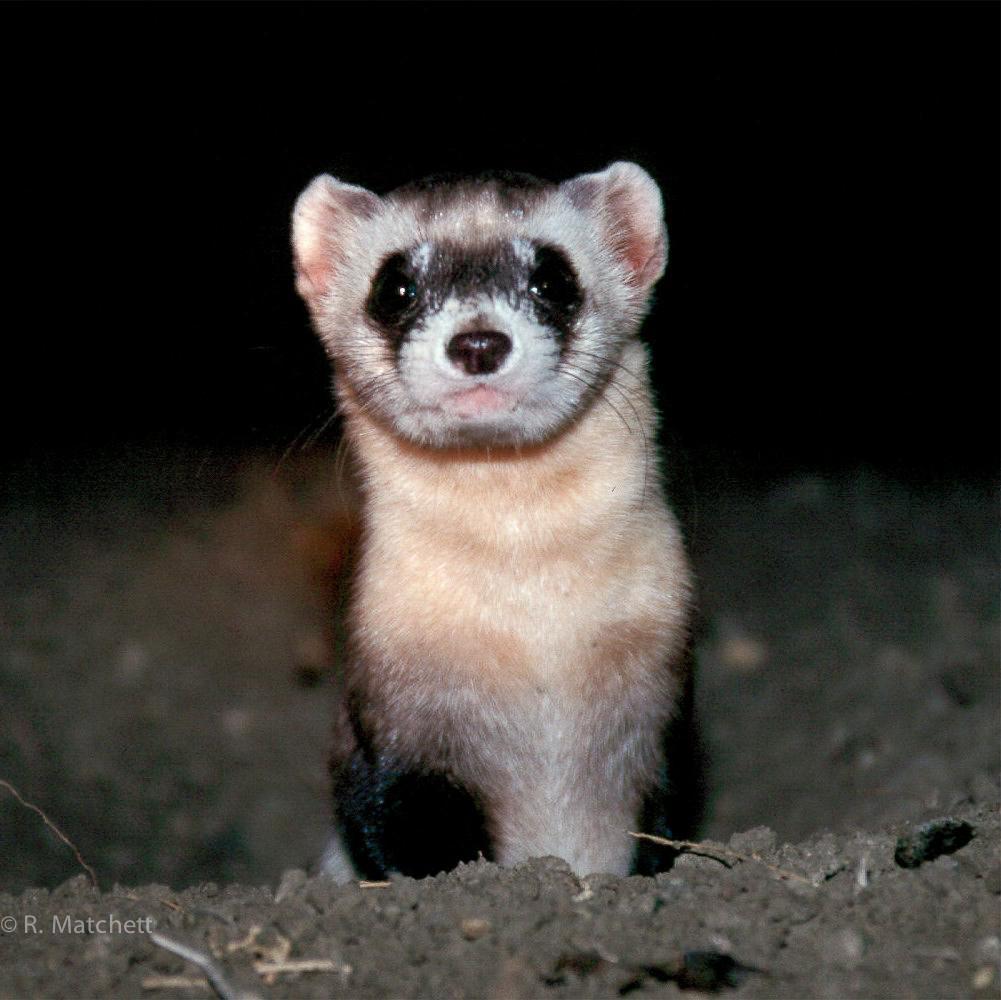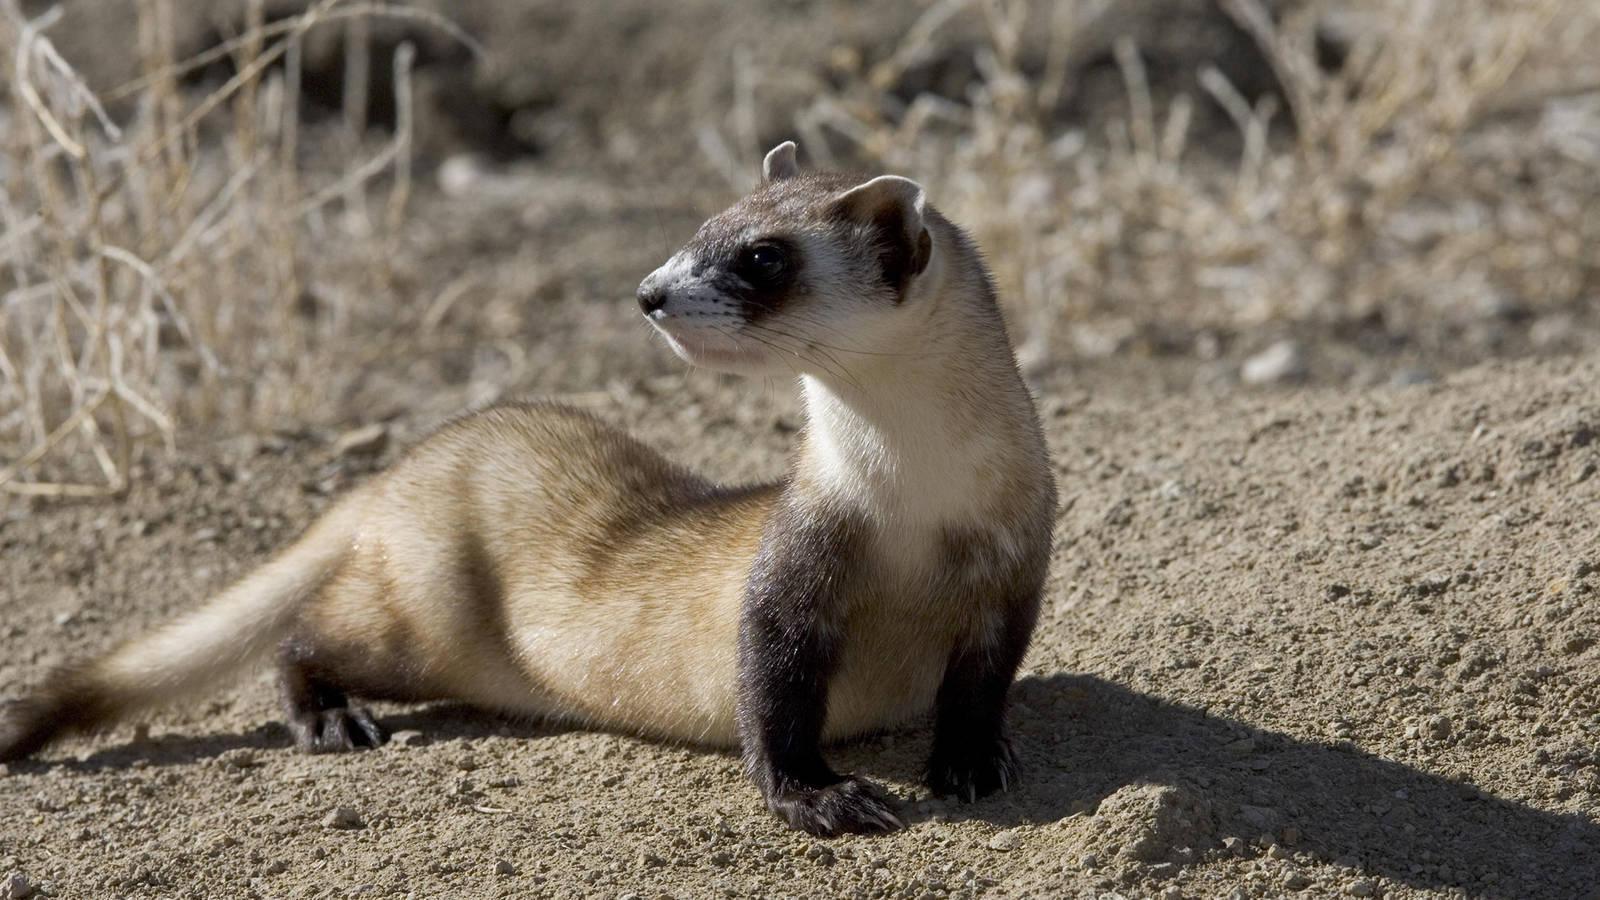The first image is the image on the left, the second image is the image on the right. Analyze the images presented: Is the assertion "One image shows a single ferret with all its feet off the ground and its face forward." valid? Answer yes or no. No. 